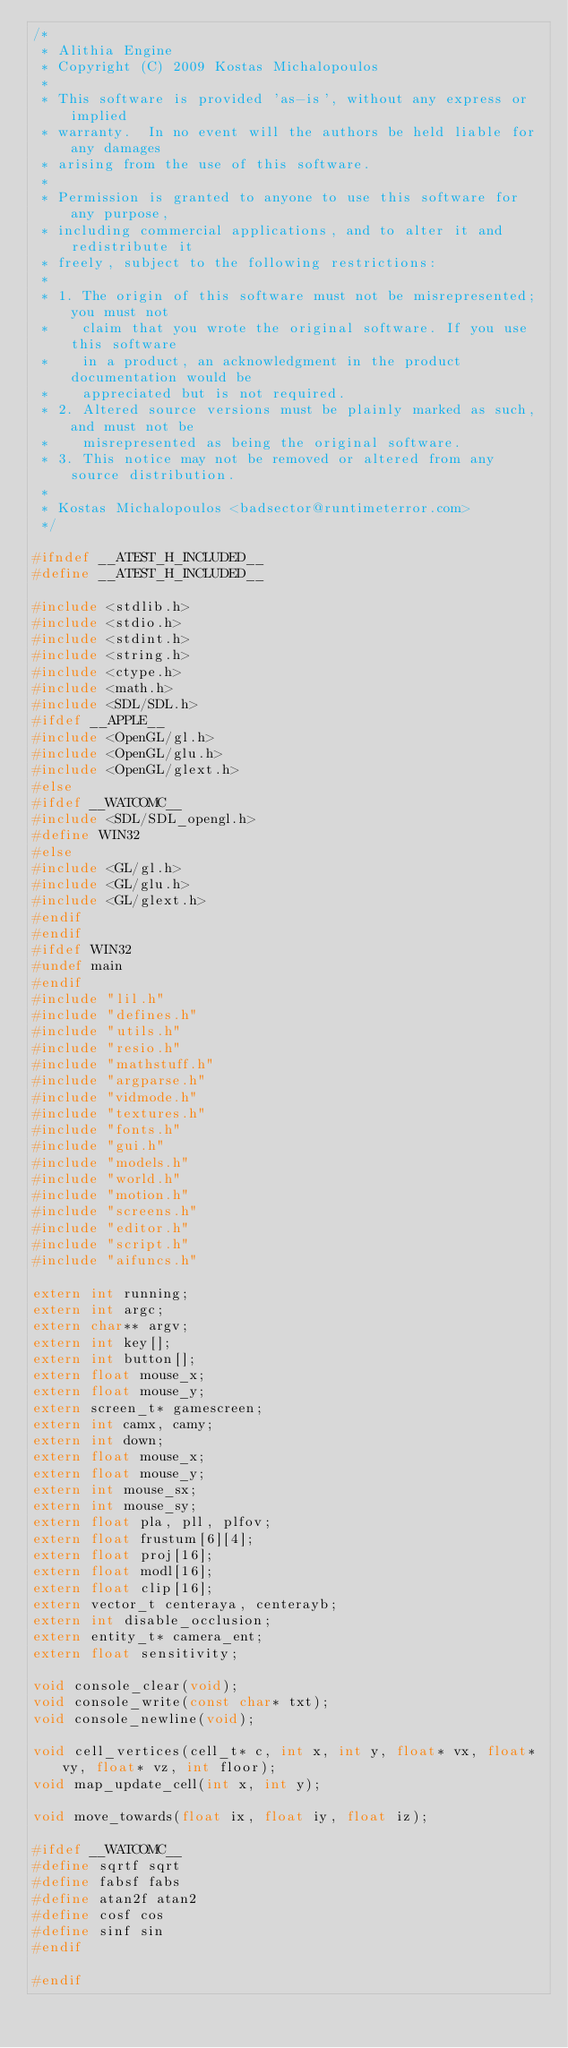Convert code to text. <code><loc_0><loc_0><loc_500><loc_500><_C_>/*
 * Alithia Engine
 * Copyright (C) 2009 Kostas Michalopoulos
 *
 * This software is provided 'as-is', without any express or implied
 * warranty.  In no event will the authors be held liable for any damages
 * arising from the use of this software.
 *
 * Permission is granted to anyone to use this software for any purpose,
 * including commercial applications, and to alter it and redistribute it
 * freely, subject to the following restrictions:
 *
 * 1. The origin of this software must not be misrepresented; you must not
 *    claim that you wrote the original software. If you use this software
 *    in a product, an acknowledgment in the product documentation would be
 *    appreciated but is not required.
 * 2. Altered source versions must be plainly marked as such, and must not be
 *    misrepresented as being the original software.
 * 3. This notice may not be removed or altered from any source distribution.
 *
 * Kostas Michalopoulos <badsector@runtimeterror.com>
 */

#ifndef __ATEST_H_INCLUDED__
#define __ATEST_H_INCLUDED__

#include <stdlib.h>
#include <stdio.h>
#include <stdint.h>
#include <string.h>
#include <ctype.h>
#include <math.h>
#include <SDL/SDL.h>
#ifdef __APPLE__
#include <OpenGL/gl.h>
#include <OpenGL/glu.h>
#include <OpenGL/glext.h>
#else
#ifdef __WATCOMC__
#include <SDL/SDL_opengl.h>
#define WIN32
#else
#include <GL/gl.h>
#include <GL/glu.h>
#include <GL/glext.h>
#endif
#endif
#ifdef WIN32
#undef main
#endif
#include "lil.h"
#include "defines.h"
#include "utils.h"
#include "resio.h"
#include "mathstuff.h"
#include "argparse.h"
#include "vidmode.h"
#include "textures.h"
#include "fonts.h"
#include "gui.h"
#include "models.h"
#include "world.h"
#include "motion.h"
#include "screens.h"
#include "editor.h"
#include "script.h"
#include "aifuncs.h"

extern int running;
extern int argc;
extern char** argv;
extern int key[];
extern int button[];
extern float mouse_x;
extern float mouse_y;
extern screen_t* gamescreen;
extern int camx, camy;
extern int down;
extern float mouse_x;
extern float mouse_y;
extern int mouse_sx;
extern int mouse_sy;
extern float pla, pll, plfov;
extern float frustum[6][4];
extern float proj[16];
extern float modl[16];
extern float clip[16];
extern vector_t centeraya, centerayb;
extern int disable_occlusion;
extern entity_t* camera_ent;
extern float sensitivity;

void console_clear(void);
void console_write(const char* txt);
void console_newline(void);

void cell_vertices(cell_t* c, int x, int y, float* vx, float* vy, float* vz, int floor);
void map_update_cell(int x, int y);

void move_towards(float ix, float iy, float iz);

#ifdef __WATCOMC__
#define sqrtf sqrt
#define fabsf fabs
#define atan2f atan2
#define cosf cos
#define sinf sin
#endif

#endif
</code> 